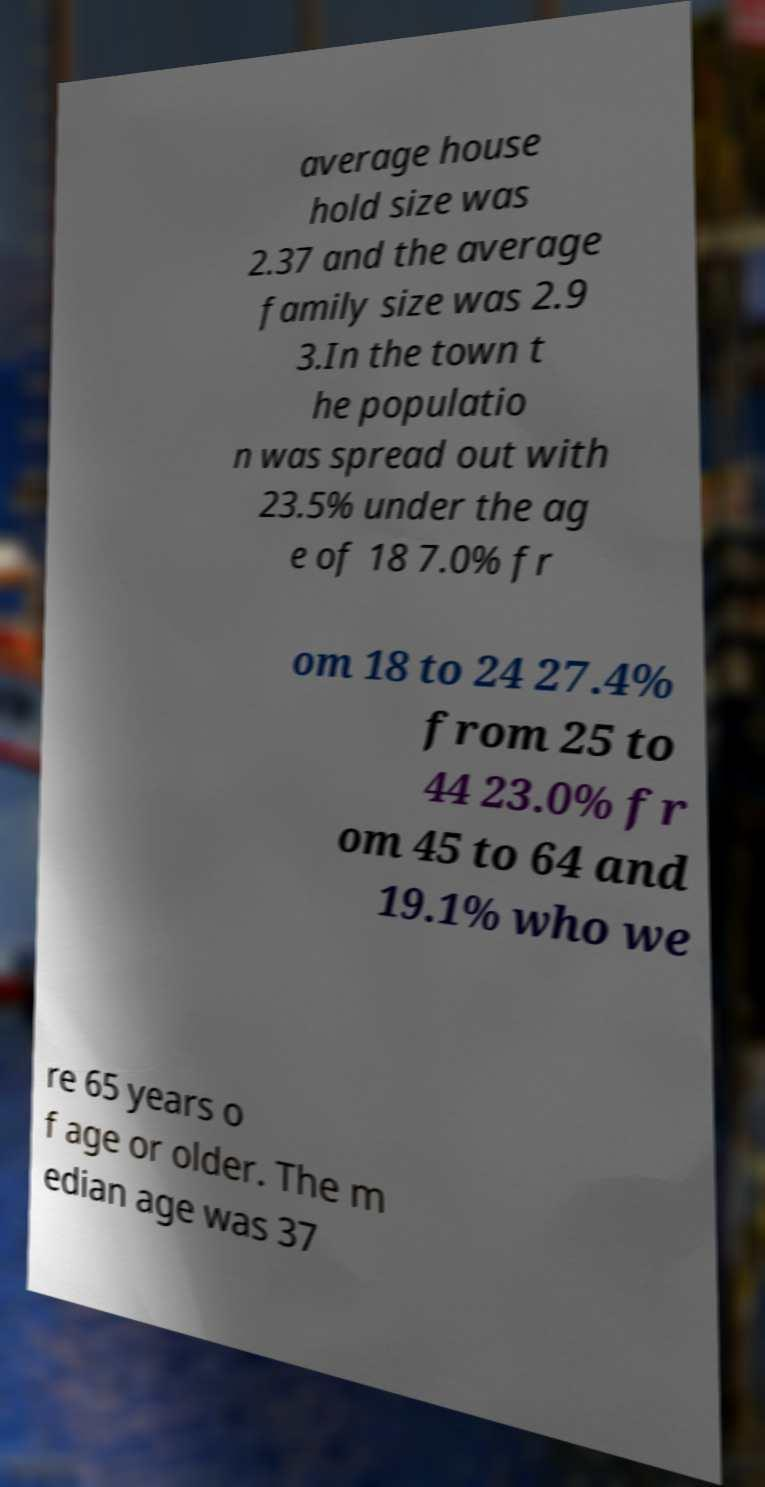Can you read and provide the text displayed in the image?This photo seems to have some interesting text. Can you extract and type it out for me? average house hold size was 2.37 and the average family size was 2.9 3.In the town t he populatio n was spread out with 23.5% under the ag e of 18 7.0% fr om 18 to 24 27.4% from 25 to 44 23.0% fr om 45 to 64 and 19.1% who we re 65 years o f age or older. The m edian age was 37 